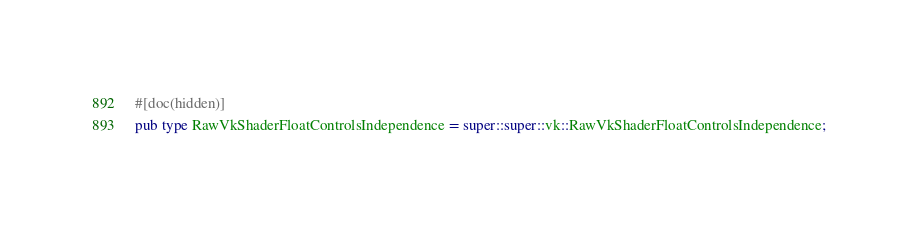<code> <loc_0><loc_0><loc_500><loc_500><_Rust_>
#[doc(hidden)]
pub type RawVkShaderFloatControlsIndependence = super::super::vk::RawVkShaderFloatControlsIndependence;</code> 